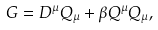Convert formula to latex. <formula><loc_0><loc_0><loc_500><loc_500>G = D ^ { \mu } Q _ { \mu } + \beta Q ^ { \mu } Q _ { \mu } ,</formula> 